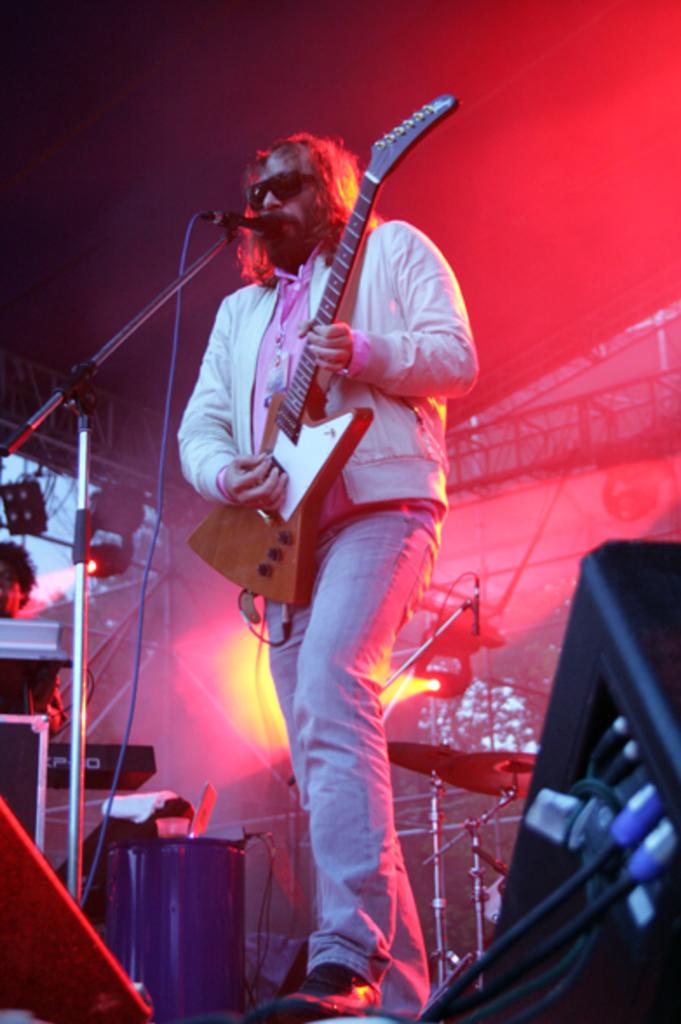What is the main subject of the image? There is a person in the image. What is the person doing in the image? The person is playing a guitar. What can be seen near the person in the image? The person is standing in front of a mic. What type of animal can be seen playing baseball in the image? There is no animal or baseball activity present in the image. How many people are in the image playing the guitar? The image only shows one person playing the guitar. 